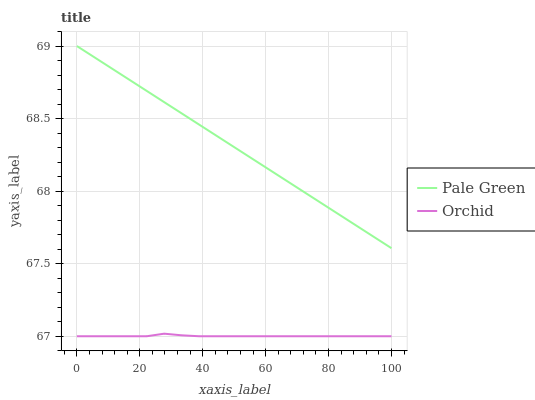Does Orchid have the minimum area under the curve?
Answer yes or no. Yes. Does Pale Green have the maximum area under the curve?
Answer yes or no. Yes. Does Orchid have the maximum area under the curve?
Answer yes or no. No. Is Pale Green the smoothest?
Answer yes or no. Yes. Is Orchid the roughest?
Answer yes or no. Yes. Is Orchid the smoothest?
Answer yes or no. No. Does Orchid have the lowest value?
Answer yes or no. Yes. Does Pale Green have the highest value?
Answer yes or no. Yes. Does Orchid have the highest value?
Answer yes or no. No. Is Orchid less than Pale Green?
Answer yes or no. Yes. Is Pale Green greater than Orchid?
Answer yes or no. Yes. Does Orchid intersect Pale Green?
Answer yes or no. No. 